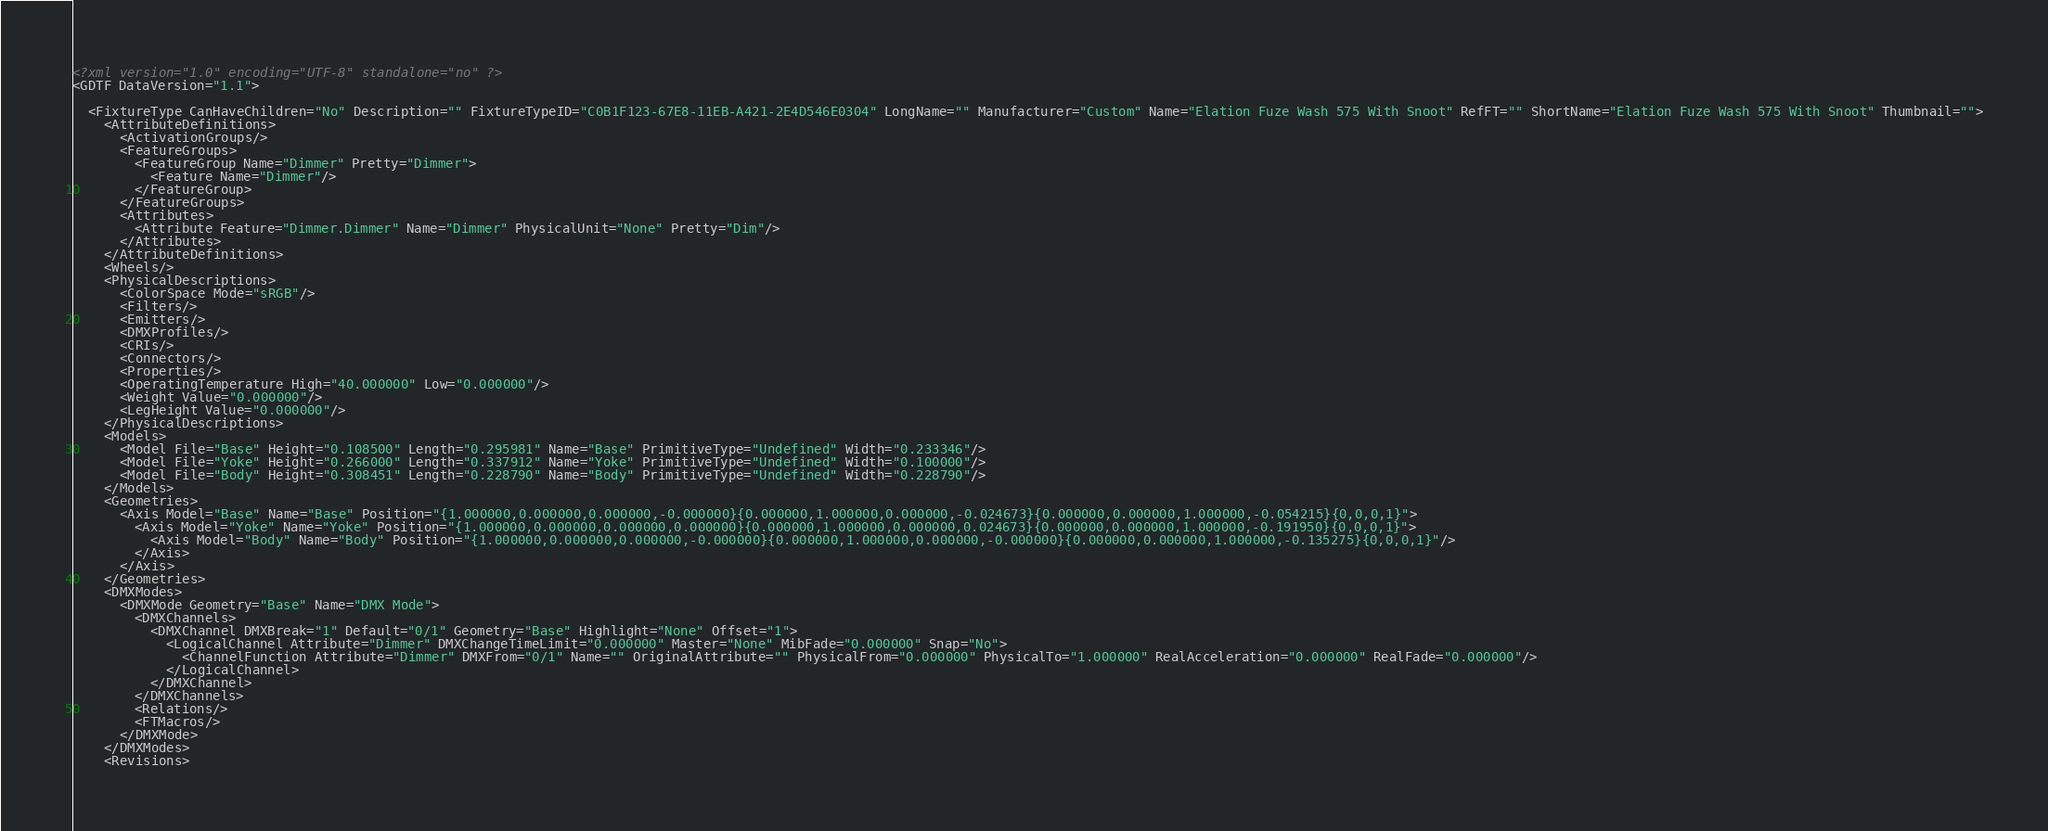Convert code to text. <code><loc_0><loc_0><loc_500><loc_500><_XML_><?xml version="1.0" encoding="UTF-8" standalone="no" ?>
<GDTF DataVersion="1.1">

  <FixtureType CanHaveChildren="No" Description="" FixtureTypeID="C0B1F123-67E8-11EB-A421-2E4D546E0304" LongName="" Manufacturer="Custom" Name="Elation Fuze Wash 575 With Snoot" RefFT="" ShortName="Elation Fuze Wash 575 With Snoot" Thumbnail="">
    <AttributeDefinitions>
      <ActivationGroups/>
      <FeatureGroups>
        <FeatureGroup Name="Dimmer" Pretty="Dimmer">
          <Feature Name="Dimmer"/>
        </FeatureGroup>
      </FeatureGroups>
      <Attributes>
        <Attribute Feature="Dimmer.Dimmer" Name="Dimmer" PhysicalUnit="None" Pretty="Dim"/>
      </Attributes>
    </AttributeDefinitions>
    <Wheels/>
    <PhysicalDescriptions>
      <ColorSpace Mode="sRGB"/>
      <Filters/>
      <Emitters/>
      <DMXProfiles/>
      <CRIs/>
      <Connectors/>
      <Properties/>
      <OperatingTemperature High="40.000000" Low="0.000000"/>
      <Weight Value="0.000000"/>
      <LegHeight Value="0.000000"/>
    </PhysicalDescriptions>
    <Models>
      <Model File="Base" Height="0.108500" Length="0.295981" Name="Base" PrimitiveType="Undefined" Width="0.233346"/>
      <Model File="Yoke" Height="0.266000" Length="0.337912" Name="Yoke" PrimitiveType="Undefined" Width="0.100000"/>
      <Model File="Body" Height="0.308451" Length="0.228790" Name="Body" PrimitiveType="Undefined" Width="0.228790"/>
    </Models>
    <Geometries>
      <Axis Model="Base" Name="Base" Position="{1.000000,0.000000,0.000000,-0.000000}{0.000000,1.000000,0.000000,-0.024673}{0.000000,0.000000,1.000000,-0.054215}{0,0,0,1}">
        <Axis Model="Yoke" Name="Yoke" Position="{1.000000,0.000000,0.000000,0.000000}{0.000000,1.000000,0.000000,0.024673}{0.000000,0.000000,1.000000,-0.191950}{0,0,0,1}">
          <Axis Model="Body" Name="Body" Position="{1.000000,0.000000,0.000000,-0.000000}{0.000000,1.000000,0.000000,-0.000000}{0.000000,0.000000,1.000000,-0.135275}{0,0,0,1}"/>
        </Axis>
      </Axis>
    </Geometries>
    <DMXModes>
      <DMXMode Geometry="Base" Name="DMX Mode">
        <DMXChannels>
          <DMXChannel DMXBreak="1" Default="0/1" Geometry="Base" Highlight="None" Offset="1">
            <LogicalChannel Attribute="Dimmer" DMXChangeTimeLimit="0.000000" Master="None" MibFade="0.000000" Snap="No">
              <ChannelFunction Attribute="Dimmer" DMXFrom="0/1" Name="" OriginalAttribute="" PhysicalFrom="0.000000" PhysicalTo="1.000000" RealAcceleration="0.000000" RealFade="0.000000"/>
            </LogicalChannel>
          </DMXChannel>
        </DMXChannels>
        <Relations/>
        <FTMacros/>
      </DMXMode>
    </DMXModes>
    <Revisions></code> 